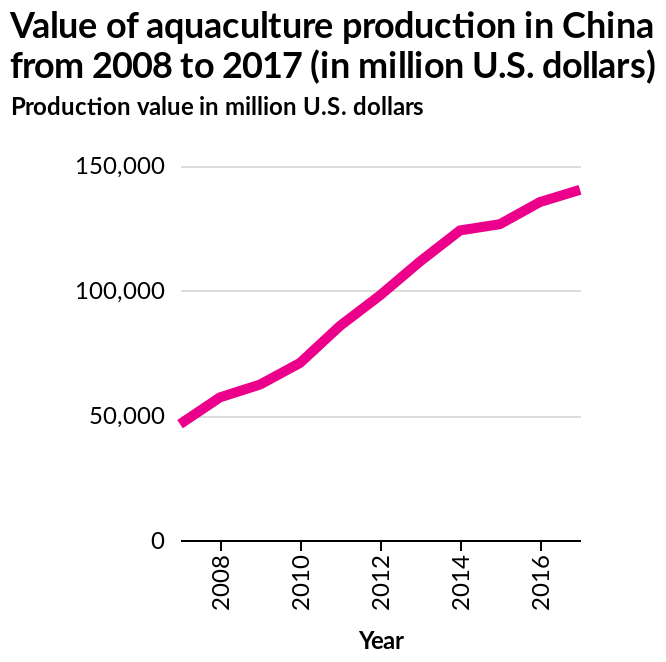<image>
What was the value of aquaculture production in China in 2008 and 2016? The value of aquaculture production in China increased from just over $50 million US dollars to just under $150 million US dollars in a four year period, between 2008 and 2016. Did the value of aquaculture production in China decrease from just over $50 million US dollars to just under $150 million US dollars in a four year period, between 2008 and 2016? No.The value of aquaculture production in China increased from just over $50 million US dollars to just under $150 million US dollars in a four year period, between 2008 and 2016. 